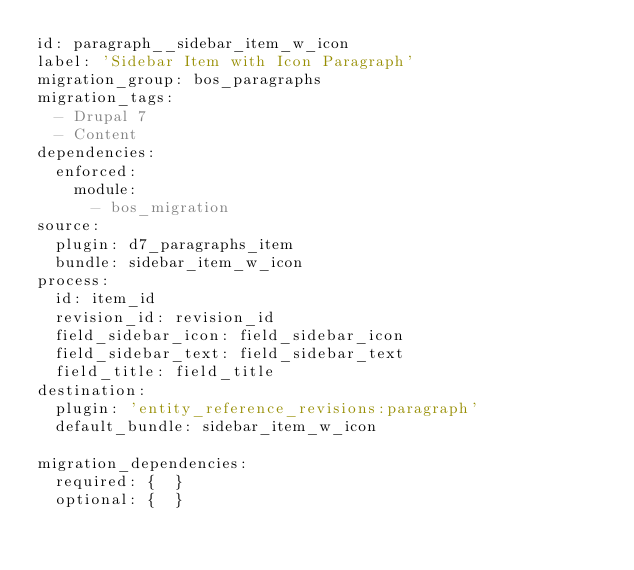Convert code to text. <code><loc_0><loc_0><loc_500><loc_500><_YAML_>id: paragraph__sidebar_item_w_icon
label: 'Sidebar Item with Icon Paragraph'
migration_group: bos_paragraphs
migration_tags:
  - Drupal 7
  - Content
dependencies:
  enforced:
    module:
      - bos_migration
source:
  plugin: d7_paragraphs_item
  bundle: sidebar_item_w_icon
process:
  id: item_id
  revision_id: revision_id
  field_sidebar_icon: field_sidebar_icon
  field_sidebar_text: field_sidebar_text
  field_title: field_title
destination:
  plugin: 'entity_reference_revisions:paragraph'
  default_bundle: sidebar_item_w_icon

migration_dependencies:
  required: {  }
  optional: {  }
</code> 